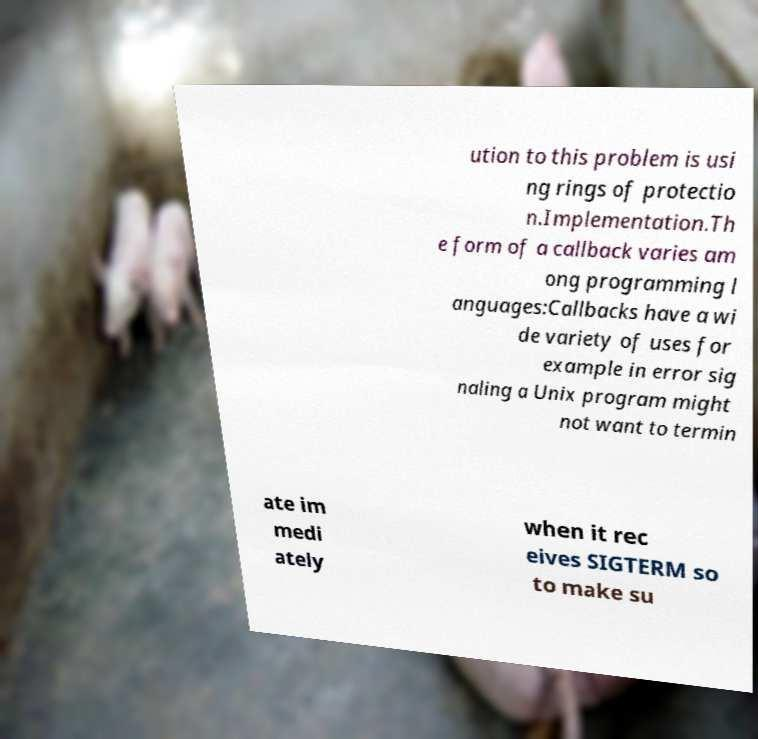There's text embedded in this image that I need extracted. Can you transcribe it verbatim? ution to this problem is usi ng rings of protectio n.Implementation.Th e form of a callback varies am ong programming l anguages:Callbacks have a wi de variety of uses for example in error sig naling a Unix program might not want to termin ate im medi ately when it rec eives SIGTERM so to make su 